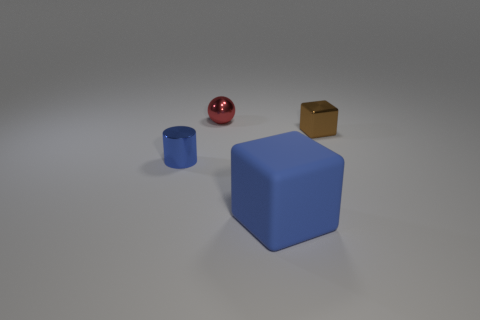Subtract 1 balls. How many balls are left? 0 Add 1 big blue cubes. How many objects exist? 5 Subtract all cylinders. How many objects are left? 3 Subtract all red balls. How many yellow cylinders are left? 0 Subtract all tiny blue shiny cylinders. Subtract all cylinders. How many objects are left? 2 Add 2 metal cylinders. How many metal cylinders are left? 3 Add 1 brown cubes. How many brown cubes exist? 2 Subtract 0 yellow cylinders. How many objects are left? 4 Subtract all green balls. Subtract all blue cubes. How many balls are left? 1 